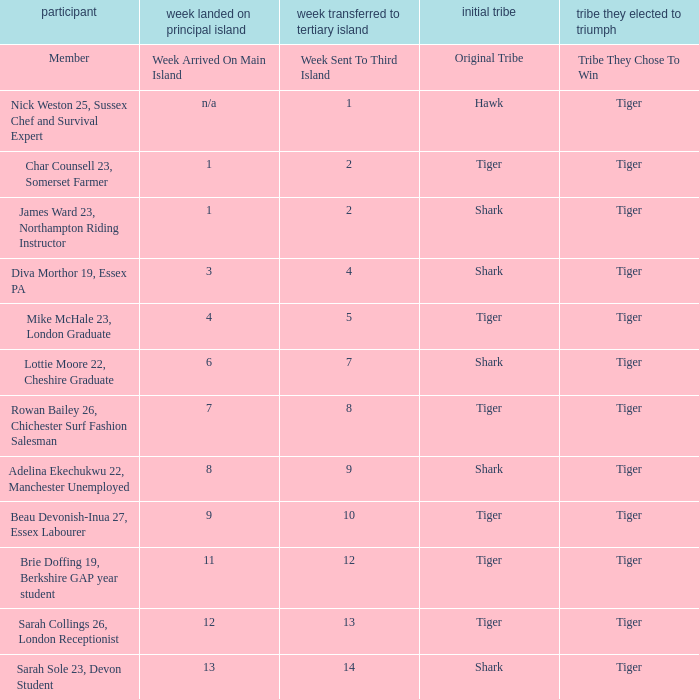During the fourth week, how many members arrived on the main island? 1.0. 